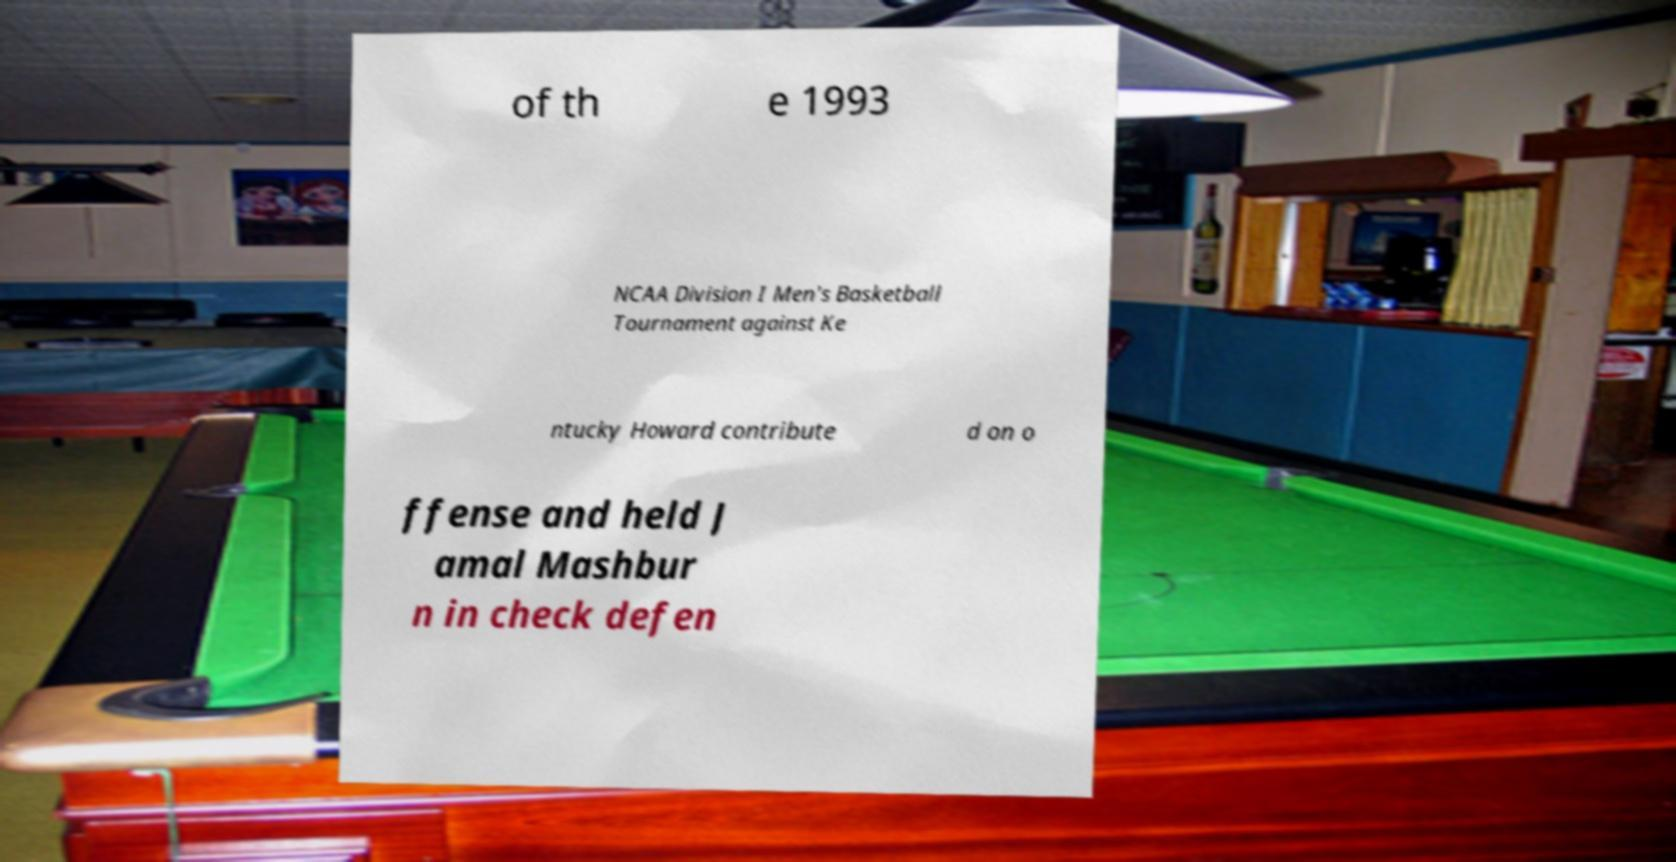Please identify and transcribe the text found in this image. of th e 1993 NCAA Division I Men's Basketball Tournament against Ke ntucky Howard contribute d on o ffense and held J amal Mashbur n in check defen 